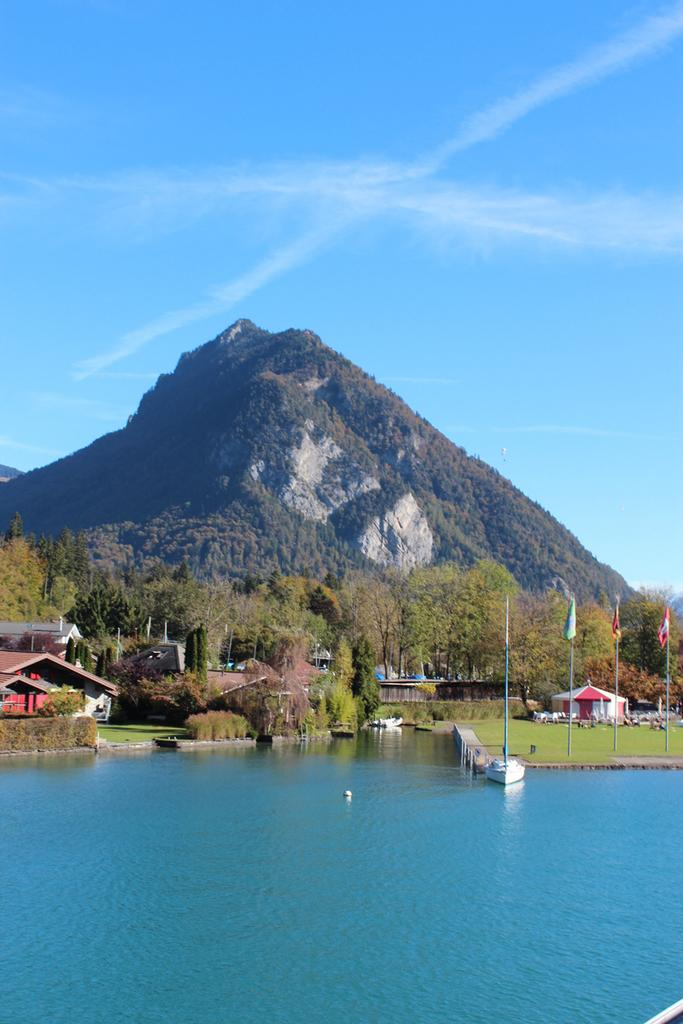What can be seen in the sky in the image? The sky with clouds is visible in the image. What type of natural features are present in the image? There are hills and trees in the image. What man-made structures can be seen in the image? Flags, flag posts, and buildings are visible in the image. What type of terrain is present in the image? Water is present in the image. What time of day is it in the image, specifically during the afternoon? The time of day is not specified in the image, and there is no indication of the afternoon. How does the rainstorm affect the visibility of the image? There is no rainstorm present in the image, so it does not affect the visibility. 